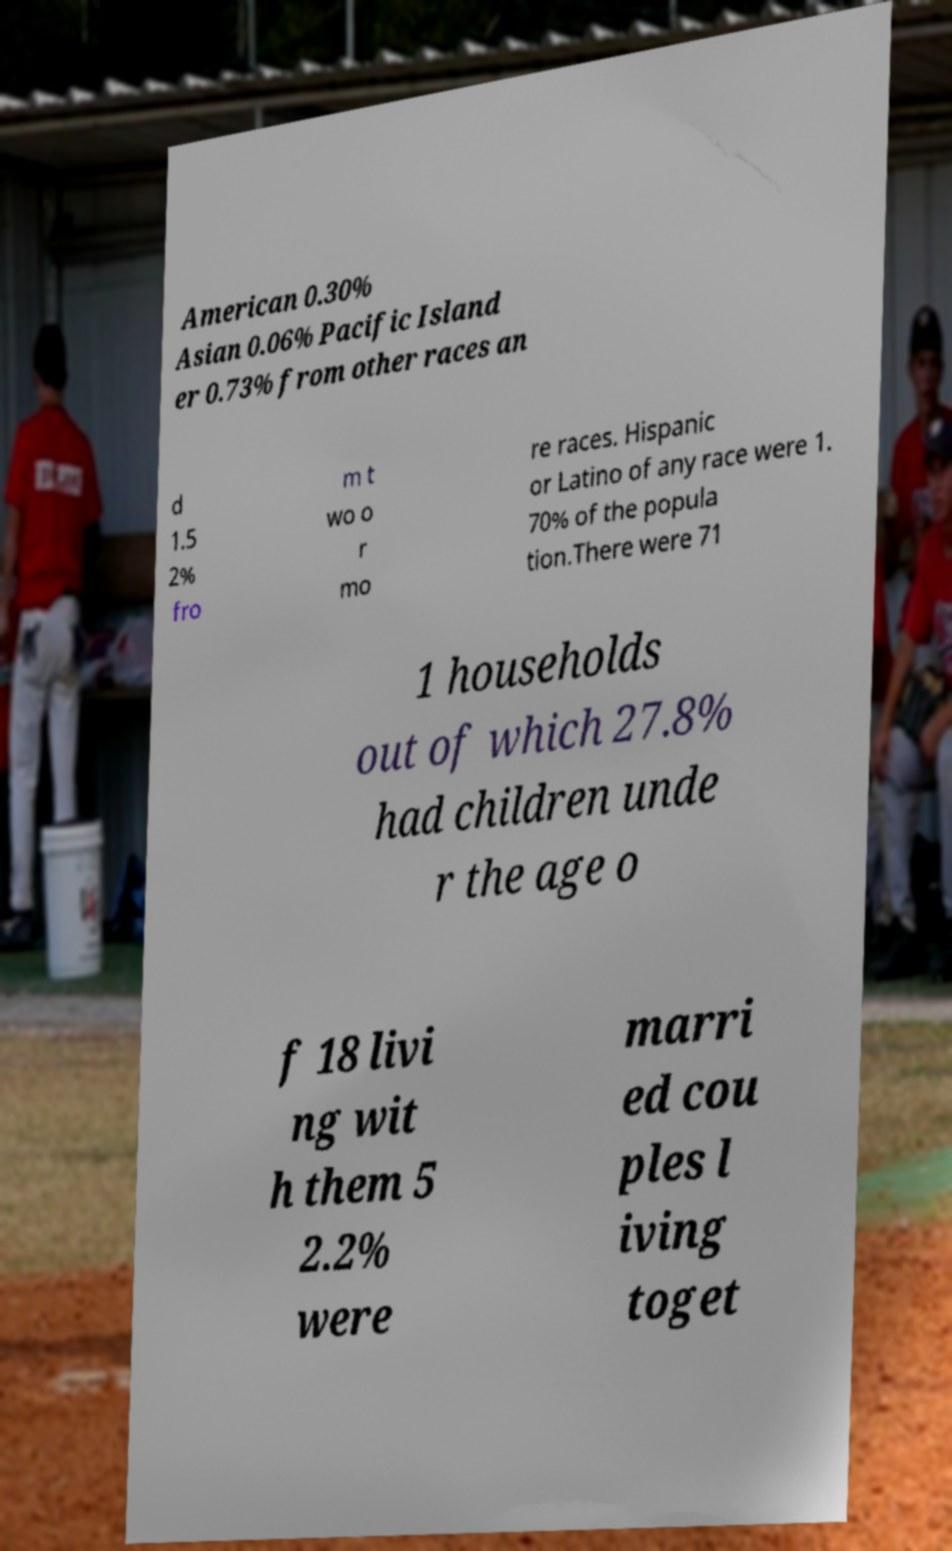I need the written content from this picture converted into text. Can you do that? American 0.30% Asian 0.06% Pacific Island er 0.73% from other races an d 1.5 2% fro m t wo o r mo re races. Hispanic or Latino of any race were 1. 70% of the popula tion.There were 71 1 households out of which 27.8% had children unde r the age o f 18 livi ng wit h them 5 2.2% were marri ed cou ples l iving toget 